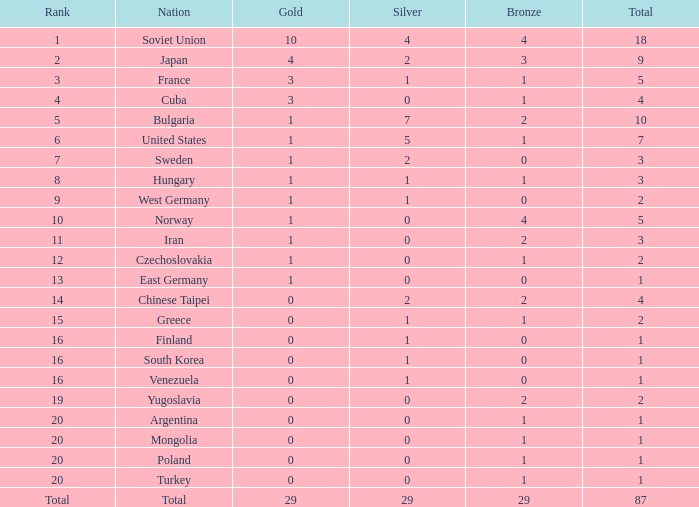What ranking consists of 1 silver medal and multiple gold medals? 3.0. 